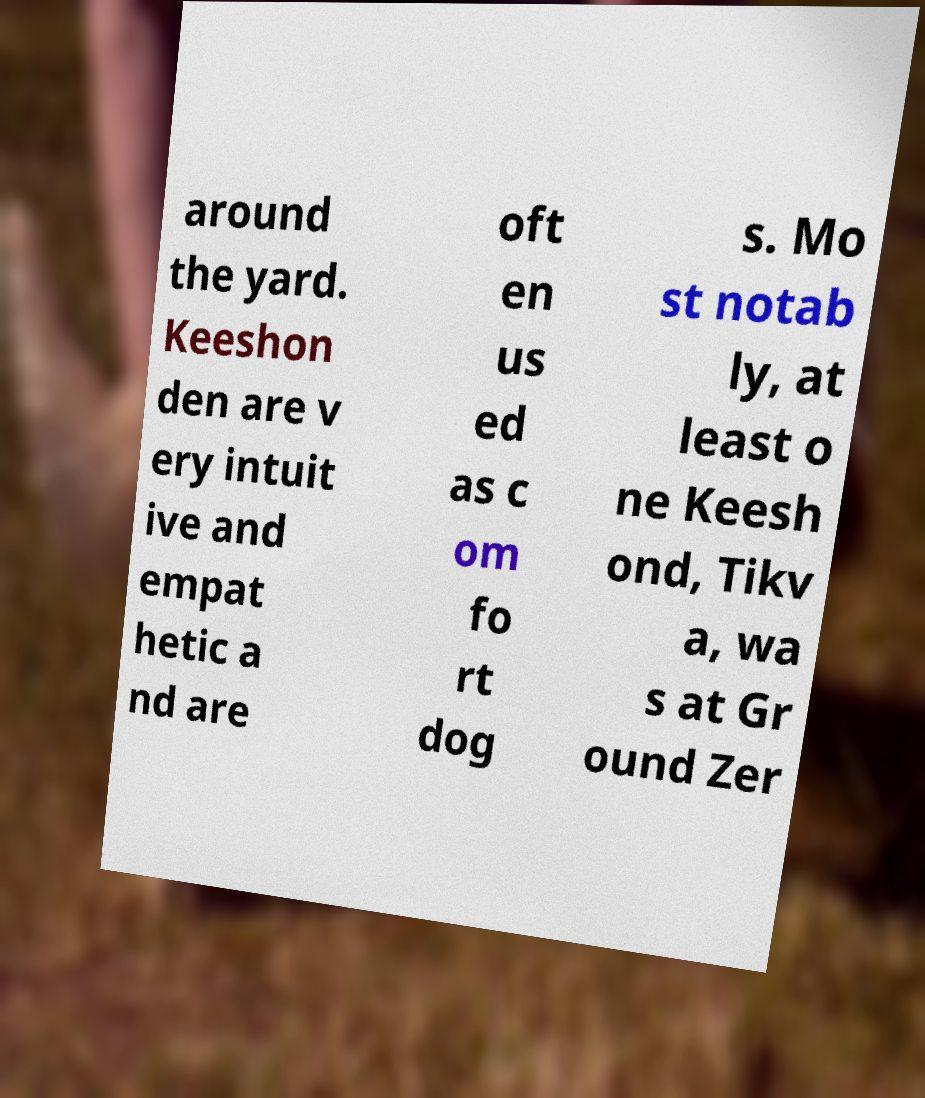For documentation purposes, I need the text within this image transcribed. Could you provide that? around the yard. Keeshon den are v ery intuit ive and empat hetic a nd are oft en us ed as c om fo rt dog s. Mo st notab ly, at least o ne Keesh ond, Tikv a, wa s at Gr ound Zer 